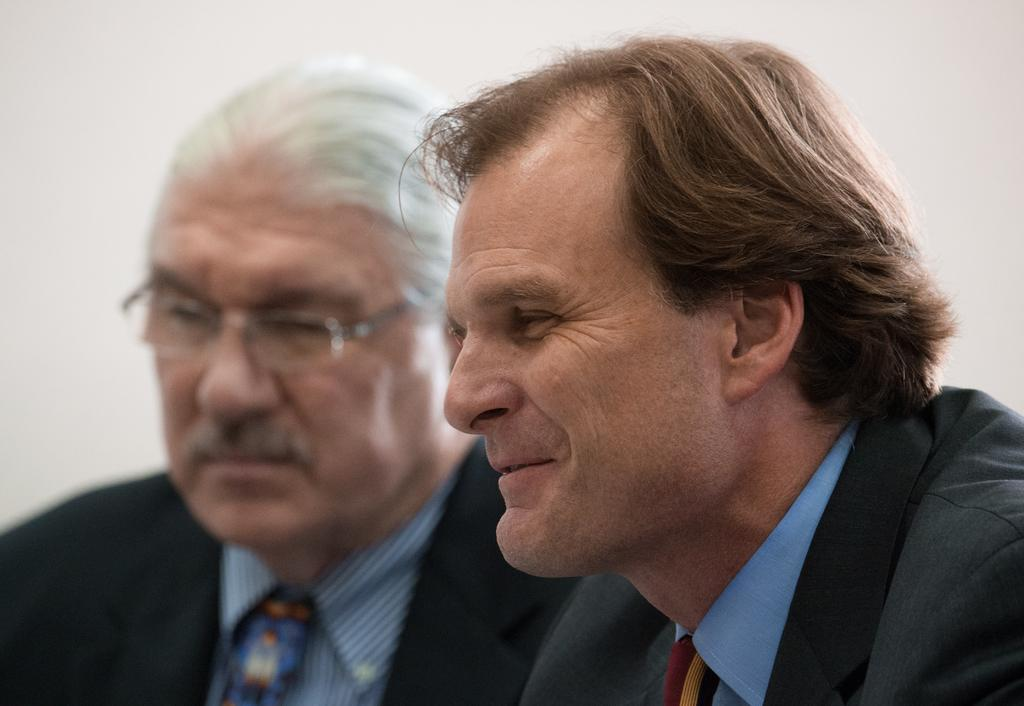How many people are in the image? There are two men in the image. What are the men wearing in the image? Both men are wearing black color blazers. What can be seen in the background of the image? There is a wall in the background of the image. Are the men driving a car in the image? No, there is no car or driving activity depicted in the image. Can you see a nest in the image? No, there is no nest present in the image. 